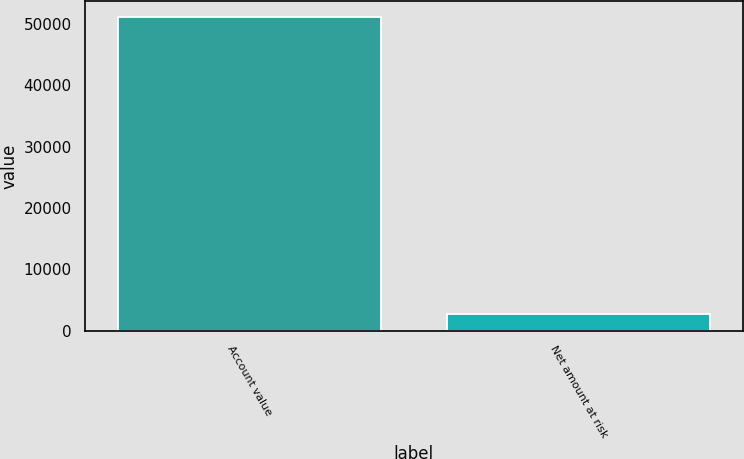<chart> <loc_0><loc_0><loc_500><loc_500><bar_chart><fcel>Account value<fcel>Net amount at risk<nl><fcel>51106<fcel>2707<nl></chart> 